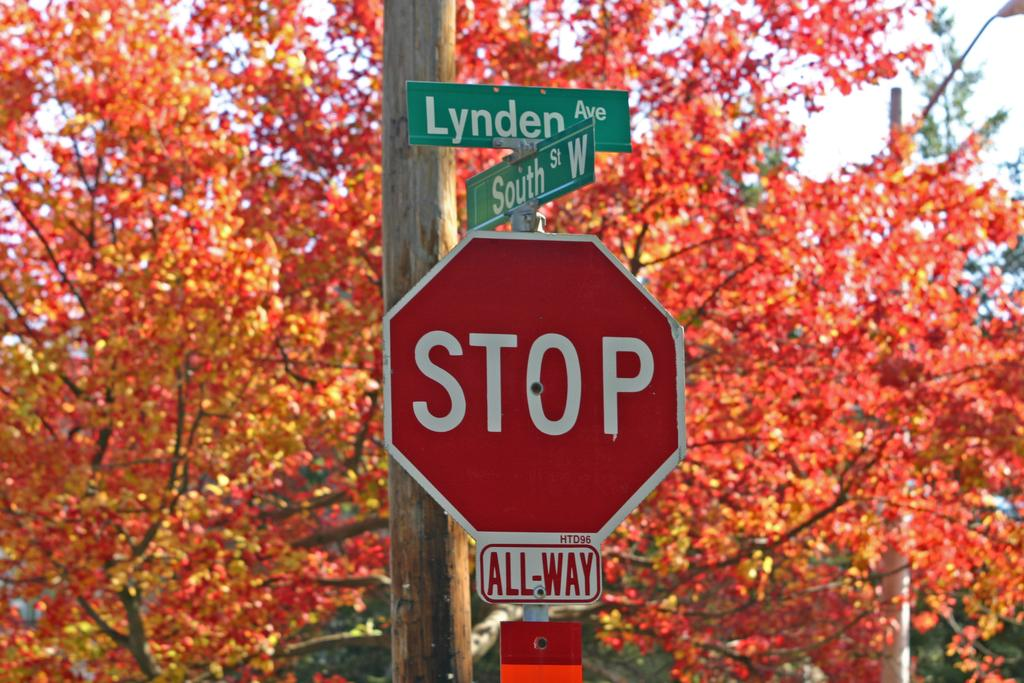<image>
Describe the image concisely. Stop sign at the corner of Lynden and South. 